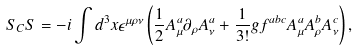<formula> <loc_0><loc_0><loc_500><loc_500>S _ { C } S = - i \int d ^ { 3 } x \epsilon ^ { \mu \rho \nu } \left ( \frac { 1 } { 2 } A _ { \mu } ^ { a } \partial _ { \rho } A _ { \nu } ^ { a } + \frac { 1 } { 3 ! } g f ^ { a b c } A _ { \mu } ^ { a } A _ { \rho } ^ { b } A _ { \nu } ^ { c } \right ) ,</formula> 